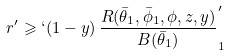Convert formula to latex. <formula><loc_0><loc_0><loc_500><loc_500>r ^ { \prime } \geqslant \lq ( 1 - y ) \, \frac { R ( \bar { \theta } _ { 1 } , \bar { \phi } _ { 1 } , \phi , z , y ) } { B ( \bar { \theta } _ { 1 } ) } \rq _ { 1 }</formula> 